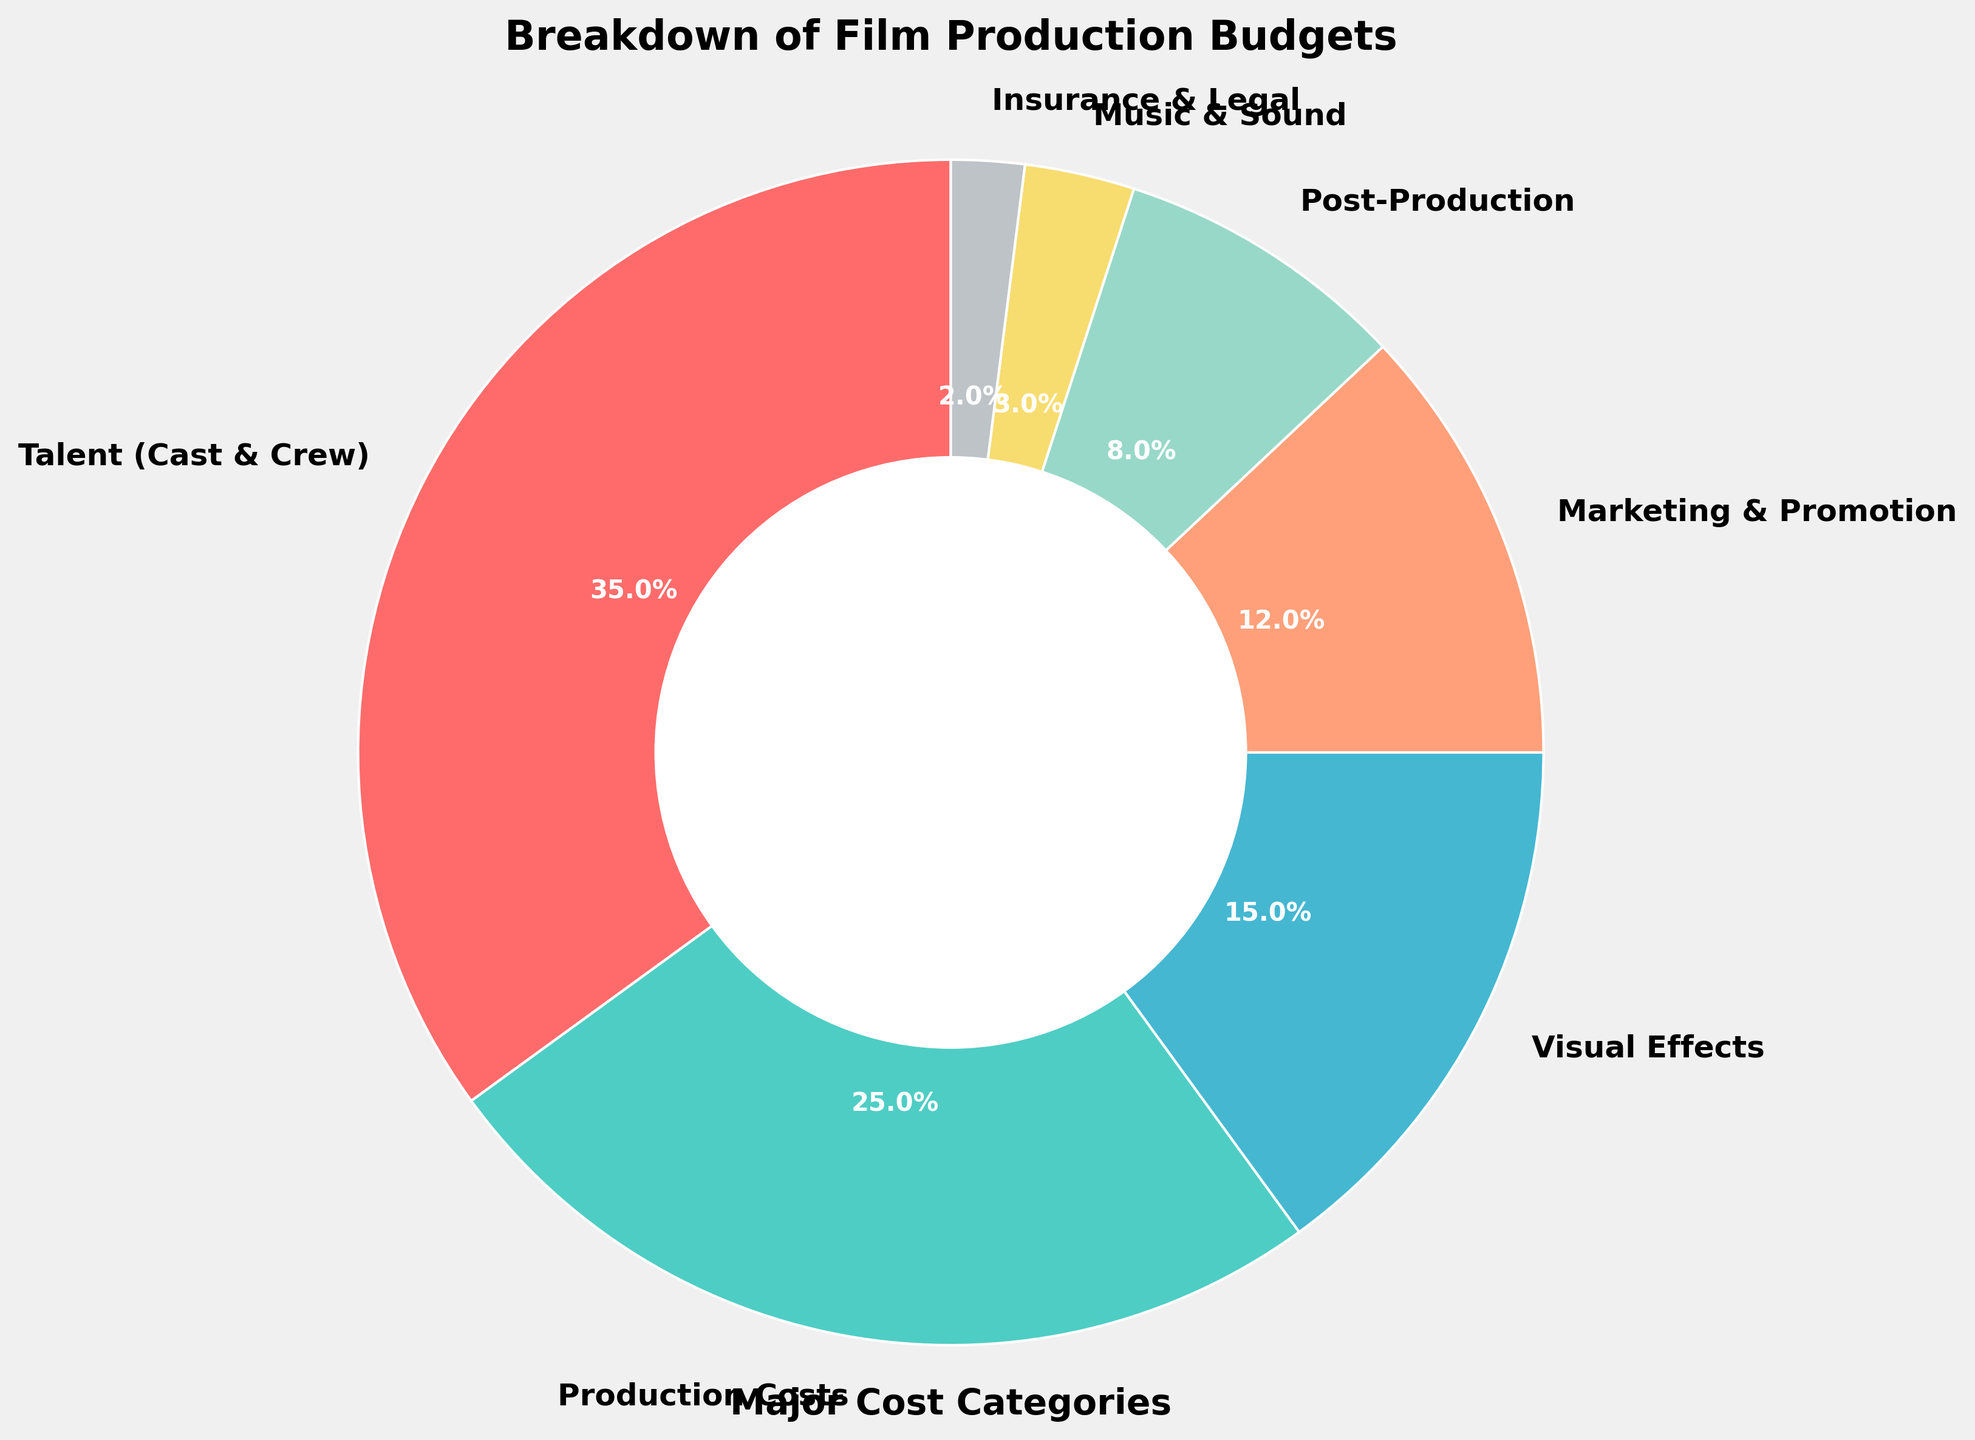What category constitutes the largest portion of the film production budget? The largest portion is represented by the segment with the highest percentage. According to the chart, this segment is labeled "Talent (Cast & Crew)" and accounts for 35%.
Answer: Talent (Cast & Crew) What is the combined percentage of Production Costs and Visual Effects? To find the combined percentage of Production Costs and Visual Effects, sum their individual percentages: 25% (Production Costs) + 15% (Visual Effects) = 40%.
Answer: 40% How much more is spent on Marketing & Promotion compared to Music & Sound? Subtract the percentage for Music & Sound from that for Marketing & Promotion: 12% (Marketing & Promotion) - 3% (Music & Sound) = 9%.
Answer: 9% What categories make up less than 10% each of the film production budget? Categories with percentages less than 10% are "Post-Production" (8%), "Music & Sound" (3%), and "Insurance & Legal" (2%).
Answer: Post-Production, Music & Sound, Insurance & Legal What is the difference between the percentage allocated to Talent (Cast & Crew) and the combined percentage for Music & Sound and Insurance & Legal? First, sum the percentages for Music & Sound and Insurance & Legal: 3% + 2% = 5%. Next, subtract this sum from the percentage for Talent (Cast & Crew): 35% - 5% = 30%.
Answer: 30% Which category justifies the third-largest budget allocation, and what is its percentage? The third-largest segment in the pie chart represents the Visual Effects category, which accounts for 15% of the budget.
Answer: Visual Effects, 15% How much larger is the allocation for Production Costs compared to Post-Production? Subtract the percentage for Post-Production from that for Production Costs: 25% (Production Costs) - 8% (Post-Production) = 17%.
Answer: 17% What two categories together make up exactly half of the film production budget? Identify and sum the percentages of two categories that together equal 50%. "Talent (Cast & Crew)" with 35% and "Production Costs" with 25% sum up to 60%, thus the next pair should be considered. It's "Talent (Cast & Crew)" with 35% and "Marketing & Promotion" with 12%. Further, 35% (Talent) + 15% (Visual Effects) = 50%.
Answer: Talent (Cast & Crew), Visual Effects What category is represented by the smallest slice, and what is its percentage? The smallest slice in the pie chart corresponds to "Insurance & Legal," which occupies 2% of the budget.
Answer: Insurance & Legal, 2% How does the percentage spent on Visual Effects compare to that on Post-Production and Music & Sound combined? First, sum the percentages for Post-Production and Music & Sound: 8% + 3% = 11%. Then compare this sum to the percentage for Visual Effects: 15% (Visual Effects) > 11% (Post-Production + Music & Sound).
Answer: Visual Effects is greater 